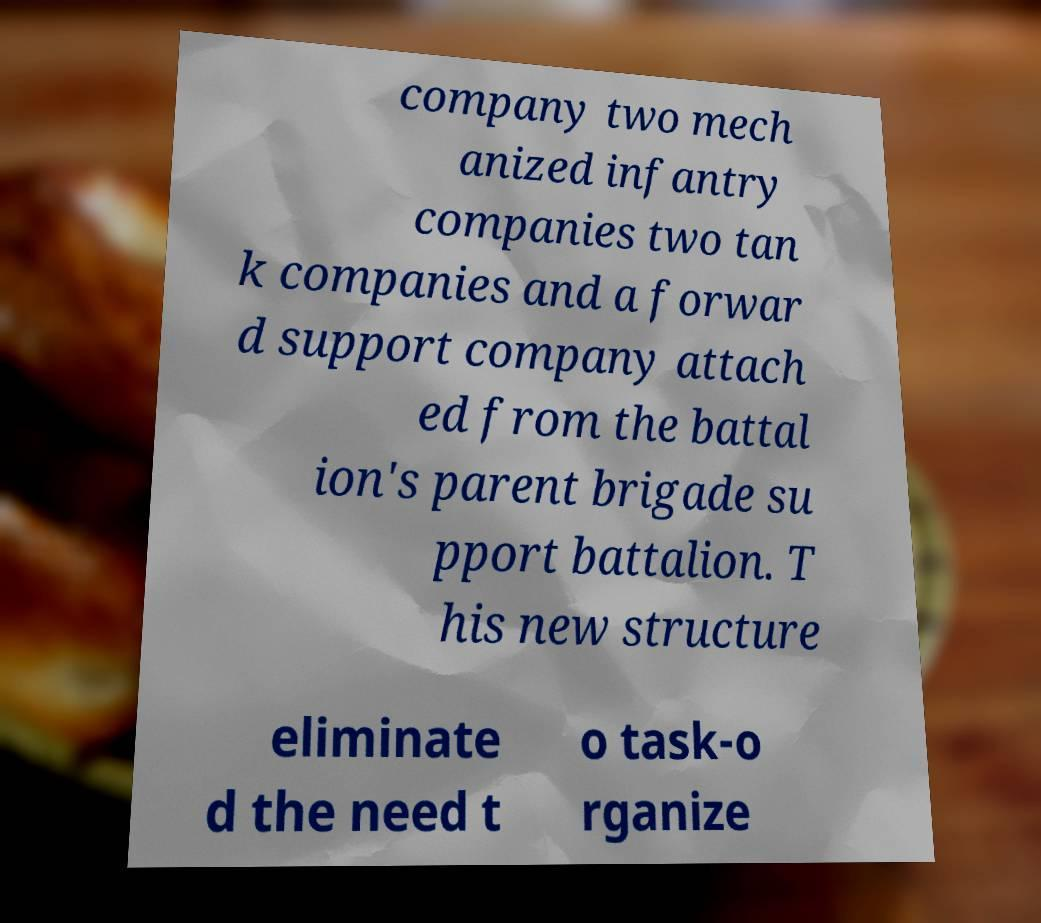Please read and relay the text visible in this image. What does it say? company two mech anized infantry companies two tan k companies and a forwar d support company attach ed from the battal ion's parent brigade su pport battalion. T his new structure eliminate d the need t o task-o rganize 